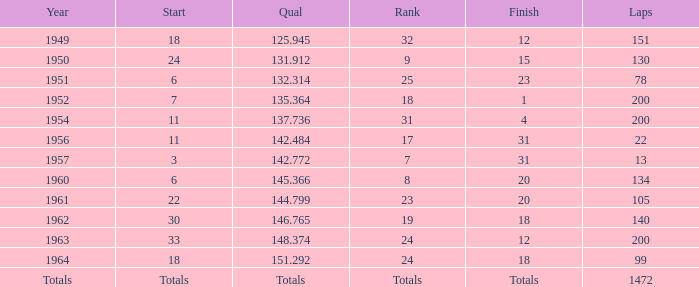Name the rank for 151 Laps 32.0. 